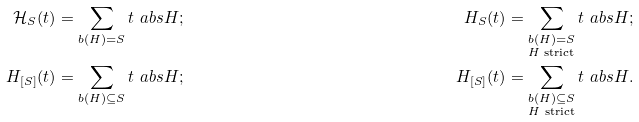Convert formula to latex. <formula><loc_0><loc_0><loc_500><loc_500>\mathcal { H } _ { S } ( t ) & = \sum _ { b ( H ) = S } t ^ { \ } a b s H \text  ; &H_{S} ( t ) & = \sum _ { \substack { b ( H ) = S \\ H \text { strict} } } t ^ { \ } a b s H \text  ;\\ \mathcal{ } H _ { [ S ] } ( t ) & = \sum _ { b ( H ) \subseteq S } t ^ { \ } a b s H \text  ; &H_{[S]} ( t ) & = \sum _ { \substack { b ( H ) \subseteq S \\ H \text { strict} } } t ^ { \ } a b s H \text  .</formula> 